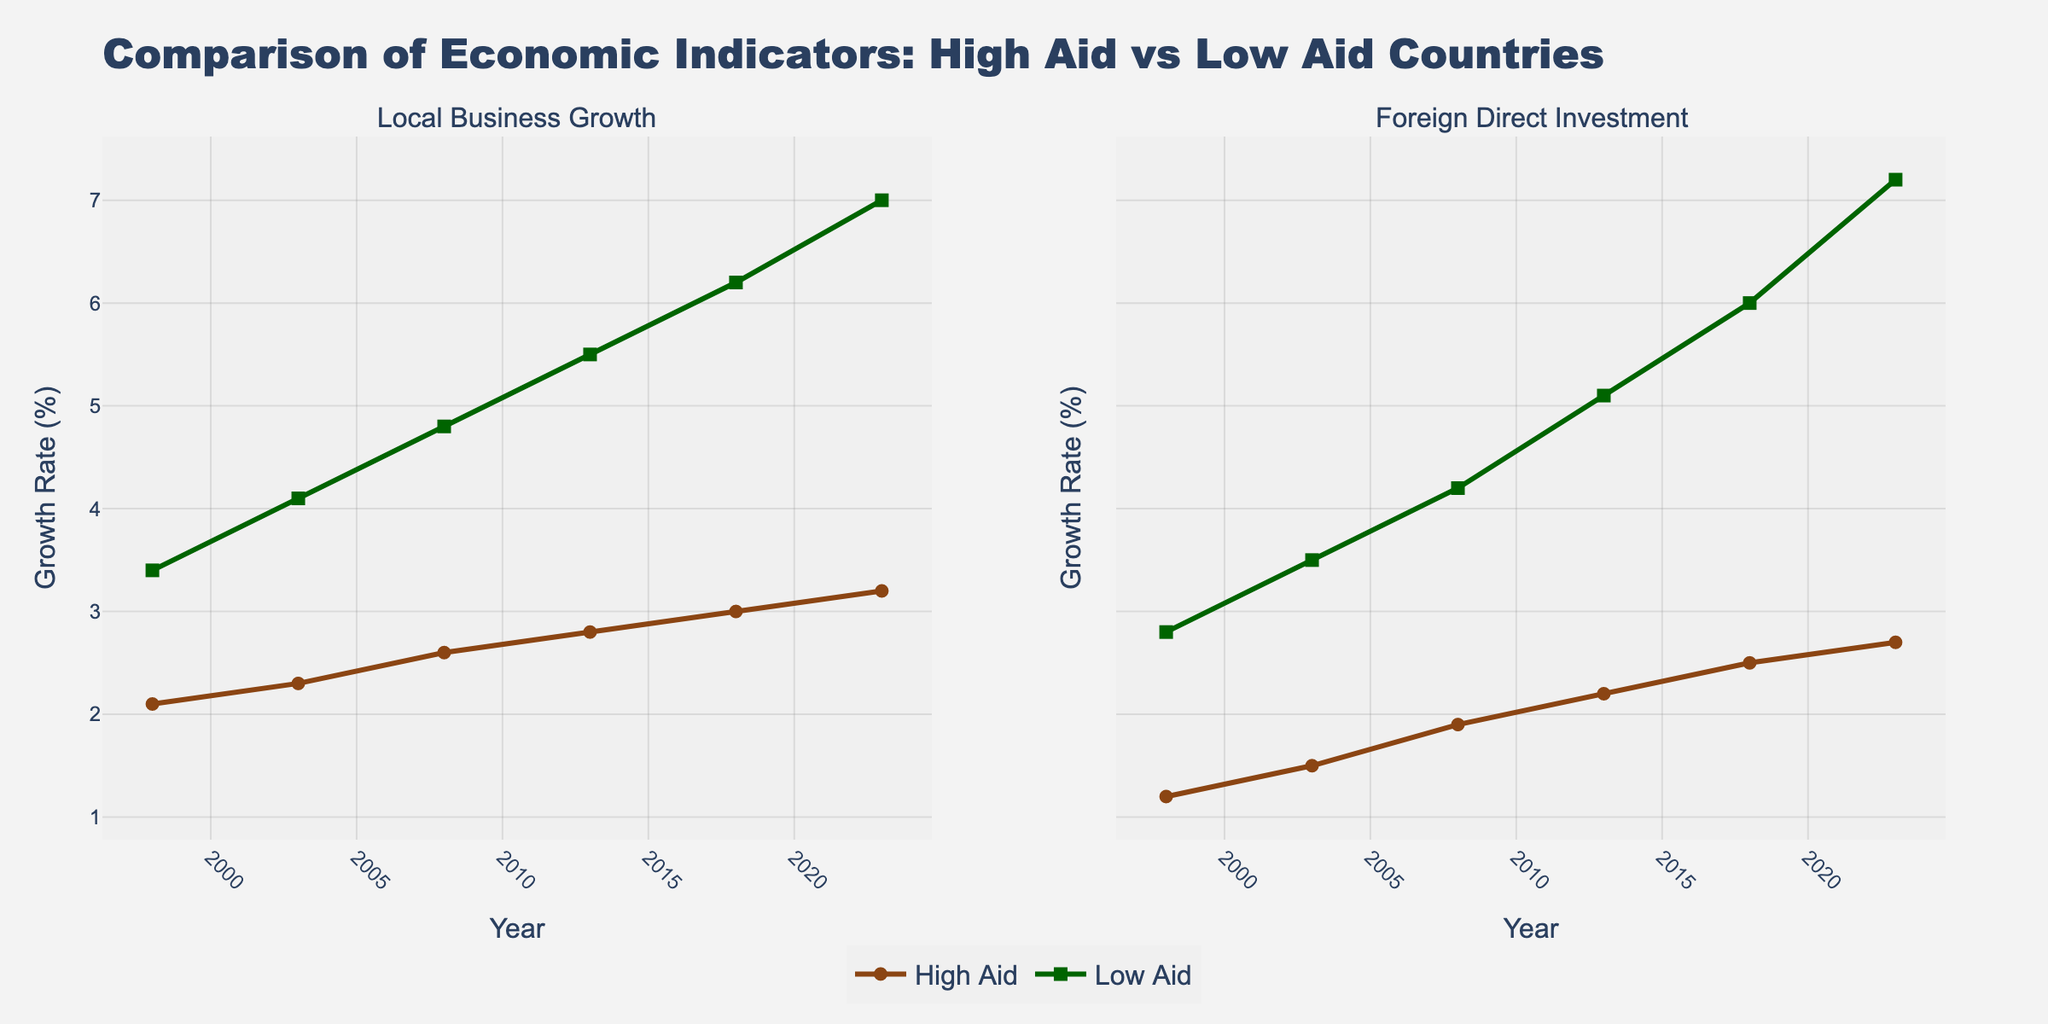what is the growth rate difference in Local Business Growth between High Aid and Low Aid countries in the year 2023? To find the difference in growth rates, subtract the growth rate of High Aid countries (3.2%) from the growth rate of Low Aid countries (7.0%). 7.0% - 3.2% equals 3.8%.
Answer: 3.8% Between 1998 and 2023, how many years observed higher Local Business Growth in Low Aid countries compared to High Aid countries? Every year between 1998 and 2023 shows higher Local Business Growth in Low Aid countries compared to High Aid countries by comparing their growth rates visually in the plot.
Answer: 6 years Did the Foreign Direct Investment (FDI) growth rate in High Aid countries increase or decrease over the 25-year span, and by how much? The FDI growth rate in High Aid countries increased from 1.2% in 1998 to 2.7% in 2023. To find the increase, subtract the initial rate from the final rate: 2.7% - 1.2% equals 1.5%.
Answer: Increase by 1.5% Which category (High Aid or Low Aid) shows a higher growth rate in Local Business Growth in 2008 and by what margin? In 2008, Local Business Growth in Low Aid countries was 4.8%, while in High Aid countries it was 2.6%. The margin is found by subtracting the growth rate of High Aid from Low Aid: 4.8% - 2.6% equals 2.2%.
Answer: Low Aid by 2.2% What was the average Foreign Direct Investment (FDI) growth rate for Low Aid countries over the given years? Add the FDI growth rates of Low Aid countries from 1998 (2.8%), 2003 (3.5%), 2008 (4.2%), 2013 (5.1%), 2018 (6.0%), and 2023 (7.2%), then divide by 6. (2.8 + 3.5 + 4.2 + 5.1 + 6.0 + 7.2) / 6 = 28.8 / 6 = 4.8%
Answer: 4.8% In which year did both High Aid and Low Aid countries exhibit the smallest difference in Foreign Direct Investment (FDI) growth rates, and what was that difference? The smallest difference can be observed in 2023. In 2023, the FDI growth rate for High Aid countries was 2.7%, and for Low Aid countries it was 7.2%. The difference is 7.2% - 2.7% = 4.5%.
Answer: 2023, 4.5% 